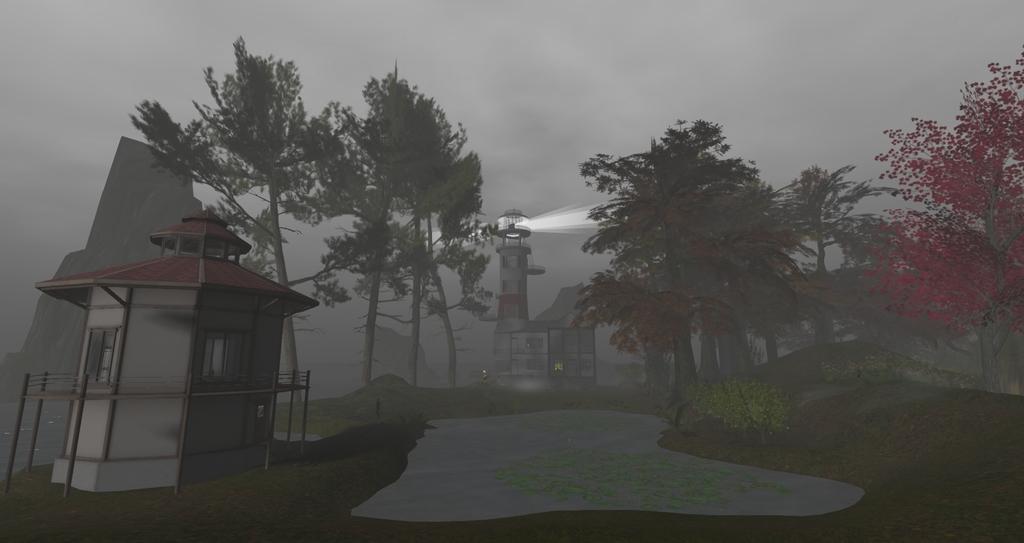Could you give a brief overview of what you see in this image? In this image there are towers, trees, plants and the sky is cloudy. 